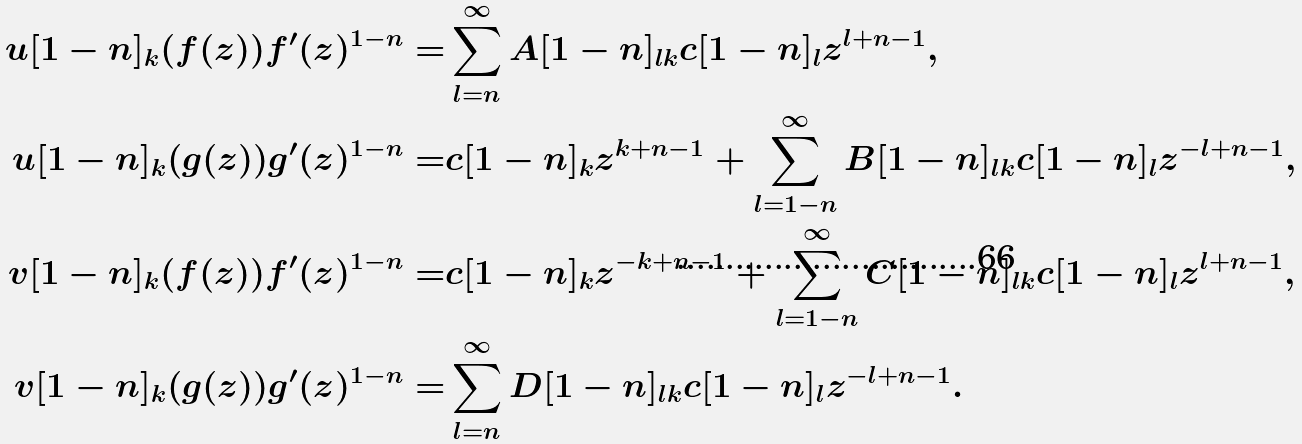Convert formula to latex. <formula><loc_0><loc_0><loc_500><loc_500>u [ 1 - n ] _ { k } ( f ( z ) ) f ^ { \prime } ( z ) ^ { 1 - n } = & \sum _ { l = n } ^ { \infty } A [ 1 - n ] _ { l k } c [ 1 - n ] _ { l } z ^ { l + n - 1 } , \\ u [ 1 - n ] _ { k } ( g ( z ) ) g ^ { \prime } ( z ) ^ { 1 - n } = & c [ 1 - n ] _ { k } z ^ { k + n - 1 } + \sum _ { l = 1 - n } ^ { \infty } B [ 1 - n ] _ { l k } c [ 1 - n ] _ { l } z ^ { - l + n - 1 } , \\ v [ 1 - n ] _ { k } ( f ( z ) ) f ^ { \prime } ( z ) ^ { 1 - n } = & c [ 1 - n ] _ { k } z ^ { - k + n - 1 } + \sum _ { l = 1 - n } ^ { \infty } C [ 1 - n ] _ { l k } c [ 1 - n ] _ { l } z ^ { l + n - 1 } , \\ v [ 1 - n ] _ { k } ( g ( z ) ) g ^ { \prime } ( z ) ^ { 1 - n } = & \sum _ { l = n } ^ { \infty } D [ 1 - n ] _ { l k } c [ 1 - n ] _ { l } z ^ { - l + n - 1 } .</formula> 